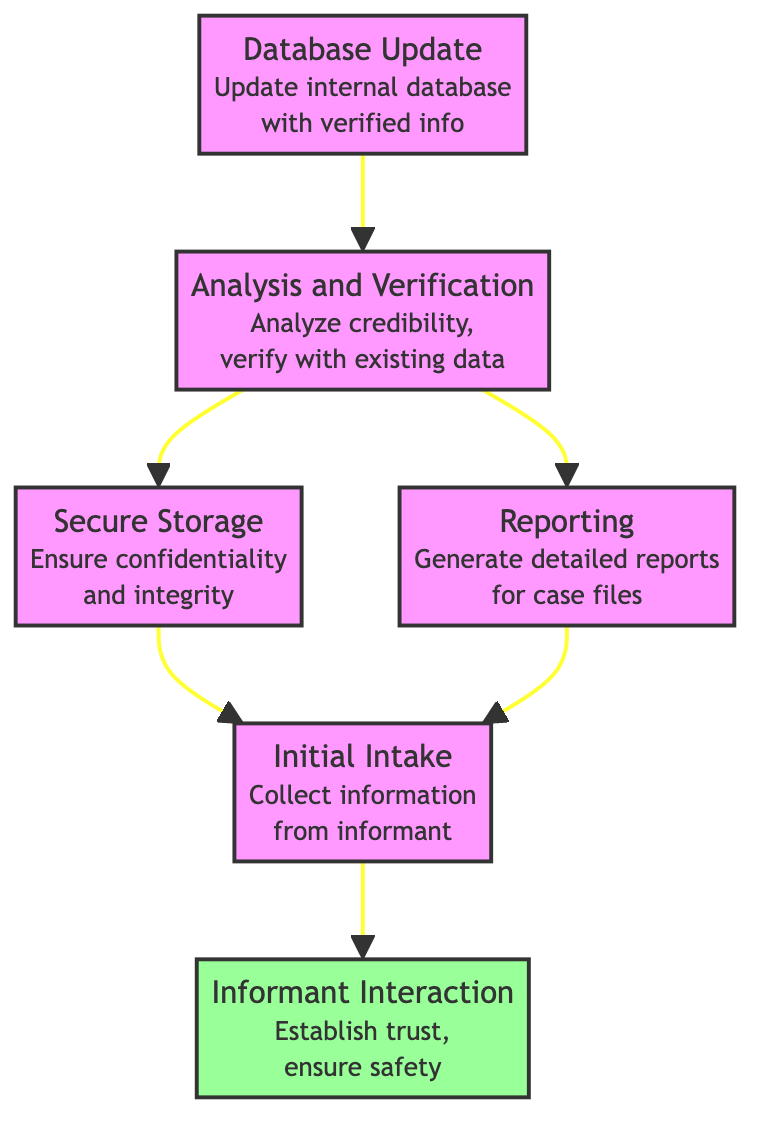What is the first step in the process? The first step in the flow chart is the "Informant Interaction," which is located at the bottom of the diagram. It is the foundation for subsequent steps.
Answer: Informant Interaction How many total nodes are in the diagram? By counting each distinct step or node provided in the diagram, there are six nodes: Database Update, Analysis and Verification, Secure Storage, Reporting, Initial Intake, and Informant Interaction.
Answer: 6 Which step comes after "Analysis and Verification"? Following the "Analysis and Verification" step, the flow progresses to "Secure Storage" and "Reporting," as both are direct successors to that node.
Answer: Secure Storage and Reporting What are the final outputs of the process? The final outputs of the process, after following the flow from top to bottom, include reports generated from the "Reporting" step, which utilize information passed down from previous steps.
Answer: Reports How many dependencies does "Reporting" have? "Reporting" has two dependencies, both of which are "Secure Storage" and "Initial Intake," indicating it requires inputs from these two steps before it can occur.
Answer: 2 What must occur before "Secure Storage"? Before "Secure Storage" can happen, "Analysis and Verification" needs to be completed as it is a direct predecessor that feeds into the storage step.
Answer: Analysis and Verification Which step ensures confidentiality? The "Secure Storage" step is responsible for maintaining confidentiality and integrity of the information collected from informants, ensuring it is kept safe.
Answer: Secure Storage What is the purpose of the "Database Update"? The purpose of "Database Update" is to ensure that the internal informant database is updated with new and verified information collected through the earlier steps in the process.
Answer: Update internal database What approach is used in "Informant Interaction"? In "Informant Interaction," establishing and maintaining trust with the informant while ensuring their safety and confidentiality is the primary approach, which is crucial for collectable information.
Answer: Establish trust and ensure safety 